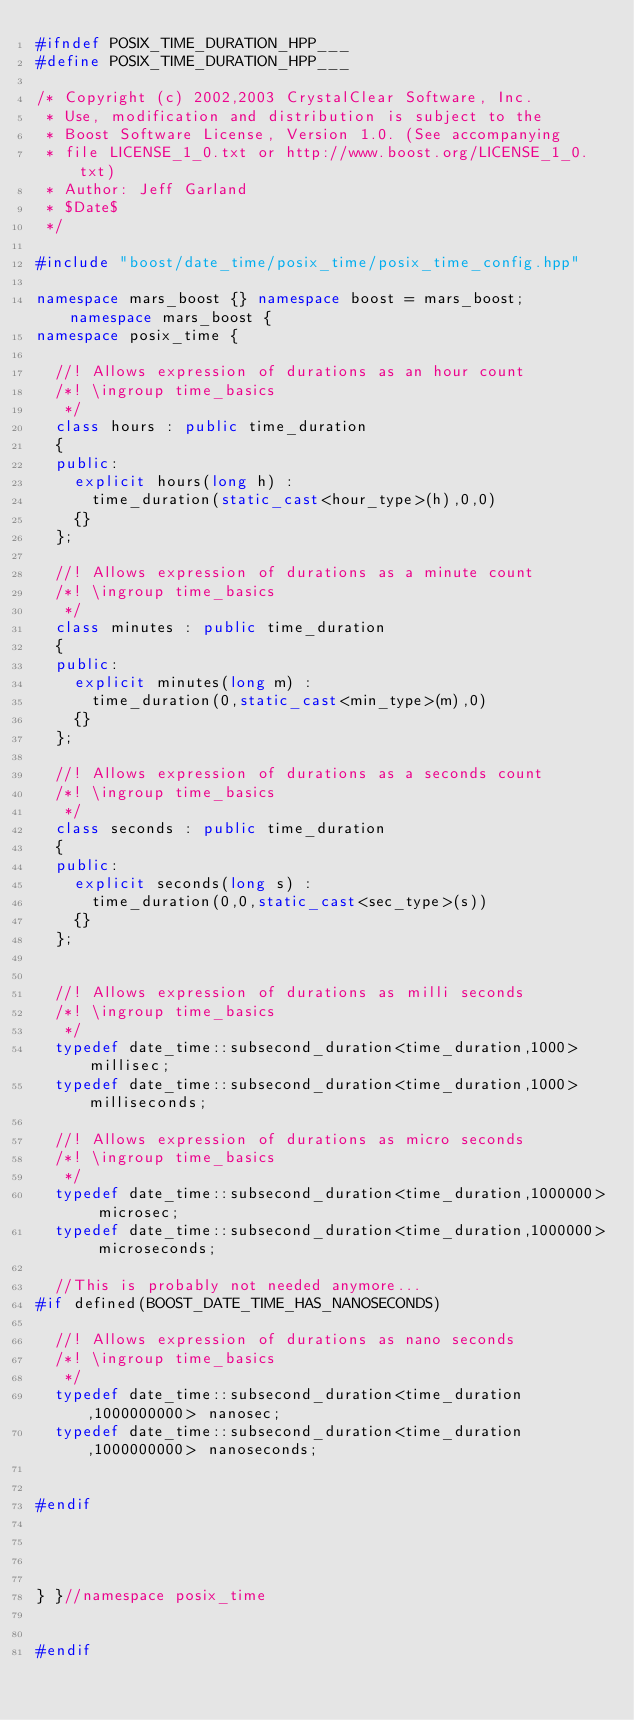<code> <loc_0><loc_0><loc_500><loc_500><_C++_>#ifndef POSIX_TIME_DURATION_HPP___
#define POSIX_TIME_DURATION_HPP___

/* Copyright (c) 2002,2003 CrystalClear Software, Inc.
 * Use, modification and distribution is subject to the 
 * Boost Software License, Version 1.0. (See accompanying
 * file LICENSE_1_0.txt or http://www.boost.org/LICENSE_1_0.txt)
 * Author: Jeff Garland
 * $Date$
 */

#include "boost/date_time/posix_time/posix_time_config.hpp"

namespace mars_boost {} namespace boost = mars_boost; namespace mars_boost {
namespace posix_time {

  //! Allows expression of durations as an hour count
  /*! \ingroup time_basics
   */
  class hours : public time_duration
  {
  public:
    explicit hours(long h) :
      time_duration(static_cast<hour_type>(h),0,0)
    {}
  };

  //! Allows expression of durations as a minute count
  /*! \ingroup time_basics
   */
  class minutes : public time_duration
  {
  public:
    explicit minutes(long m) :
      time_duration(0,static_cast<min_type>(m),0)
    {}
  };

  //! Allows expression of durations as a seconds count
  /*! \ingroup time_basics
   */
  class seconds : public time_duration
  {
  public:
    explicit seconds(long s) :
      time_duration(0,0,static_cast<sec_type>(s))
    {}
  };


  //! Allows expression of durations as milli seconds
  /*! \ingroup time_basics
   */
  typedef date_time::subsecond_duration<time_duration,1000> millisec;
  typedef date_time::subsecond_duration<time_duration,1000> milliseconds;

  //! Allows expression of durations as micro seconds
  /*! \ingroup time_basics
   */
  typedef date_time::subsecond_duration<time_duration,1000000> microsec;
  typedef date_time::subsecond_duration<time_duration,1000000> microseconds;

  //This is probably not needed anymore...
#if defined(BOOST_DATE_TIME_HAS_NANOSECONDS)

  //! Allows expression of durations as nano seconds
  /*! \ingroup time_basics
   */
  typedef date_time::subsecond_duration<time_duration,1000000000> nanosec;
  typedef date_time::subsecond_duration<time_duration,1000000000> nanoseconds;


#endif




} }//namespace posix_time


#endif

</code> 